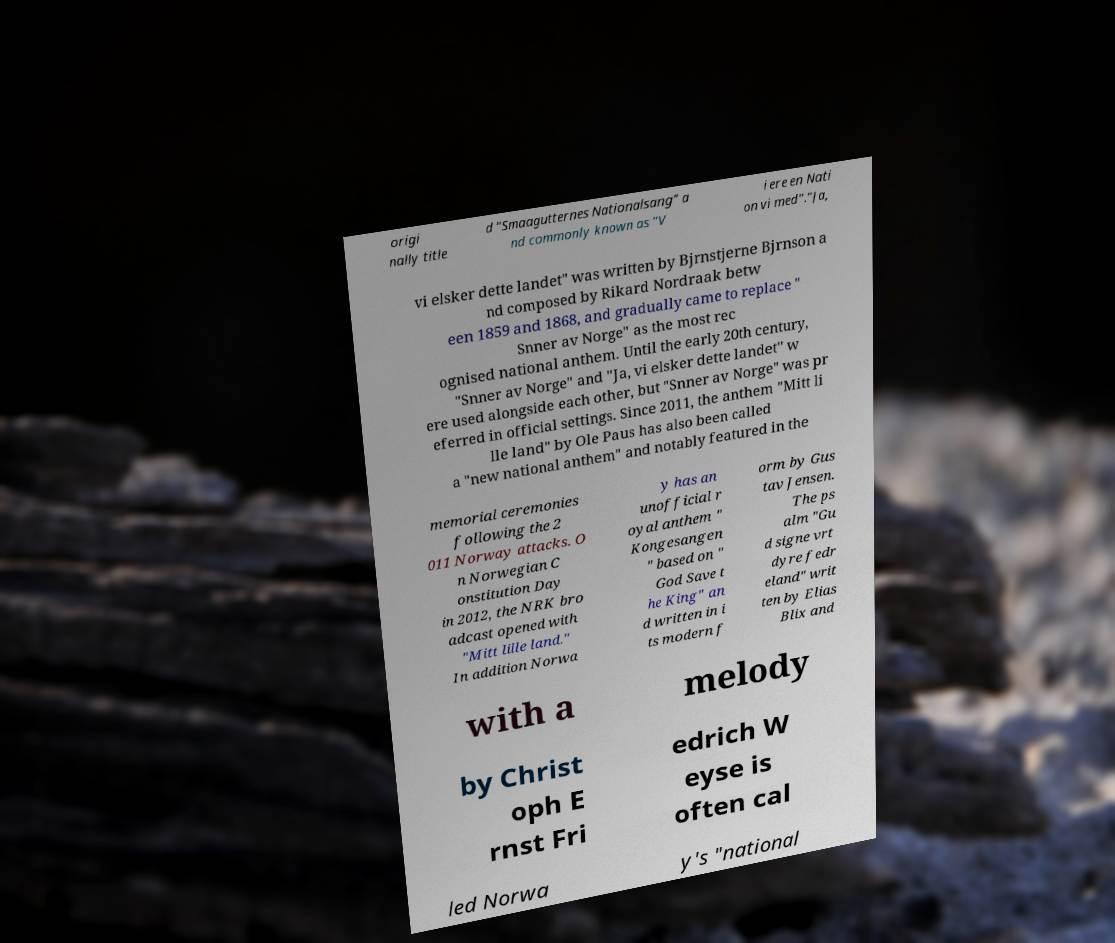I need the written content from this picture converted into text. Can you do that? origi nally title d "Smaagutternes Nationalsang" a nd commonly known as "V i ere en Nati on vi med"."Ja, vi elsker dette landet" was written by Bjrnstjerne Bjrnson a nd composed by Rikard Nordraak betw een 1859 and 1868, and gradually came to replace " Snner av Norge" as the most rec ognised national anthem. Until the early 20th century, "Snner av Norge" and "Ja, vi elsker dette landet" w ere used alongside each other, but "Snner av Norge" was pr eferred in official settings. Since 2011, the anthem "Mitt li lle land" by Ole Paus has also been called a "new national anthem" and notably featured in the memorial ceremonies following the 2 011 Norway attacks. O n Norwegian C onstitution Day in 2012, the NRK bro adcast opened with "Mitt lille land." In addition Norwa y has an unofficial r oyal anthem " Kongesangen " based on " God Save t he King" an d written in i ts modern f orm by Gus tav Jensen. The ps alm "Gu d signe vrt dyre fedr eland" writ ten by Elias Blix and with a melody by Christ oph E rnst Fri edrich W eyse is often cal led Norwa y's "national 